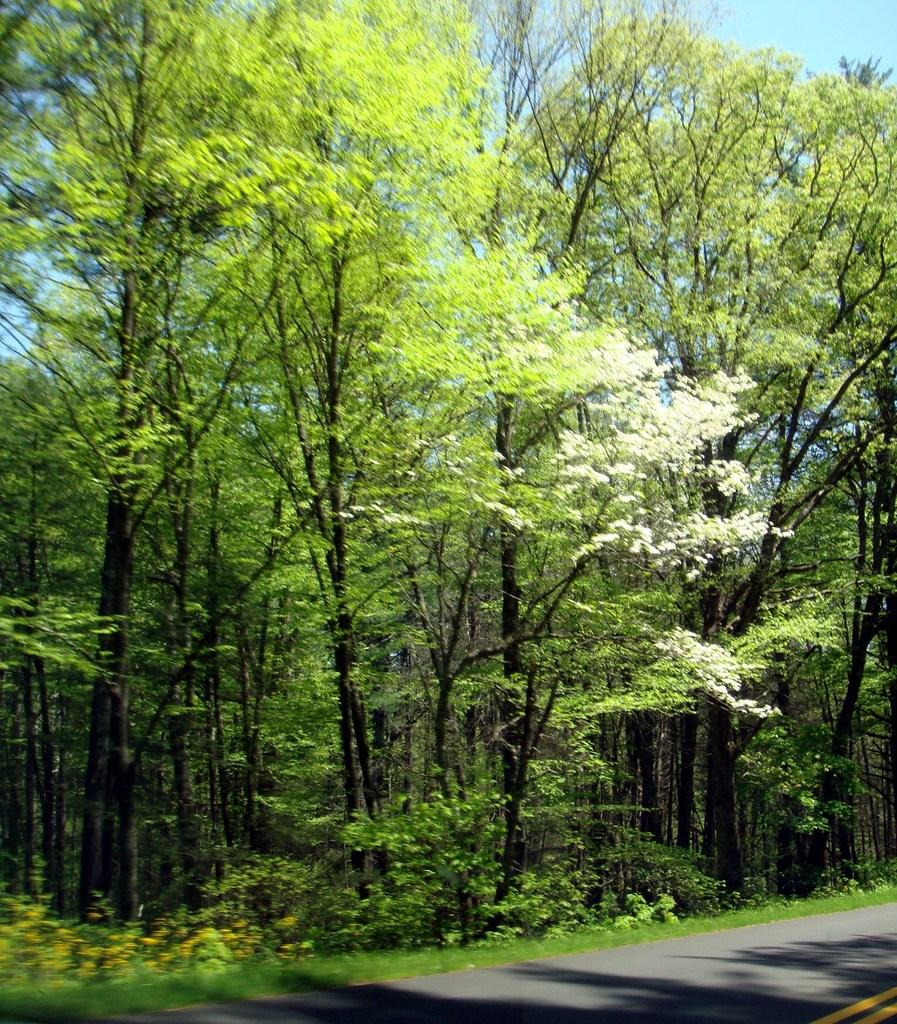What type of surface can be seen in the image? There is a road in the image. What type of vegetation is present in the image? There is grass and trees in the image. What can be seen in the background of the image? The sky is visible in the background of the image. Is there any poison visible in the image? There is no poison present in the image. What season is depicted in the image, considering the presence of spring flowers? The image does not show any specific season, as there is no mention of spring flowers or any other seasonal indicators. 